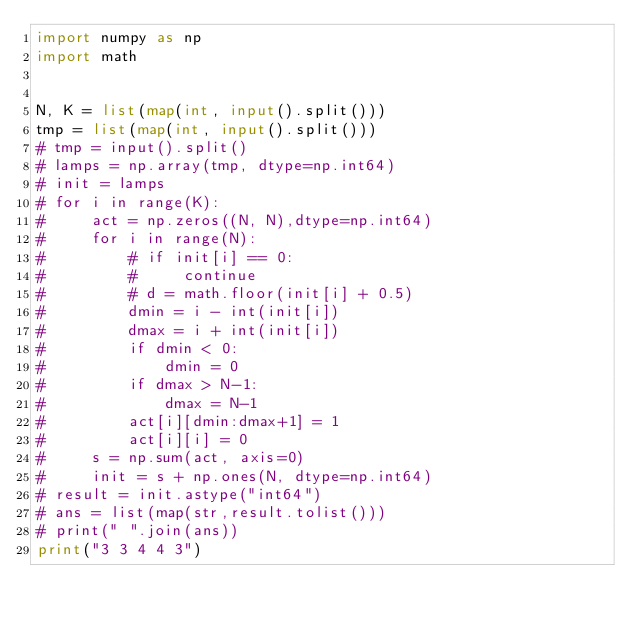<code> <loc_0><loc_0><loc_500><loc_500><_Python_>import numpy as np
import math


N, K = list(map(int, input().split()))
tmp = list(map(int, input().split()))
# tmp = input().split()
# lamps = np.array(tmp, dtype=np.int64)
# init = lamps
# for i in range(K):
#     act = np.zeros((N, N),dtype=np.int64)
#     for i in range(N):
#         # if init[i] == 0:
#         #     continue
#         # d = math.floor(init[i] + 0.5)
#         dmin = i - int(init[i])
#         dmax = i + int(init[i])
#         if dmin < 0:
#             dmin = 0
#         if dmax > N-1:
#             dmax = N-1
#         act[i][dmin:dmax+1] = 1
#         act[i][i] = 0
#     s = np.sum(act, axis=0)
#     init = s + np.ones(N, dtype=np.int64)
# result = init.astype("int64")
# ans = list(map(str,result.tolist()))
# print(" ".join(ans))
print("3 3 4 4 3")</code> 